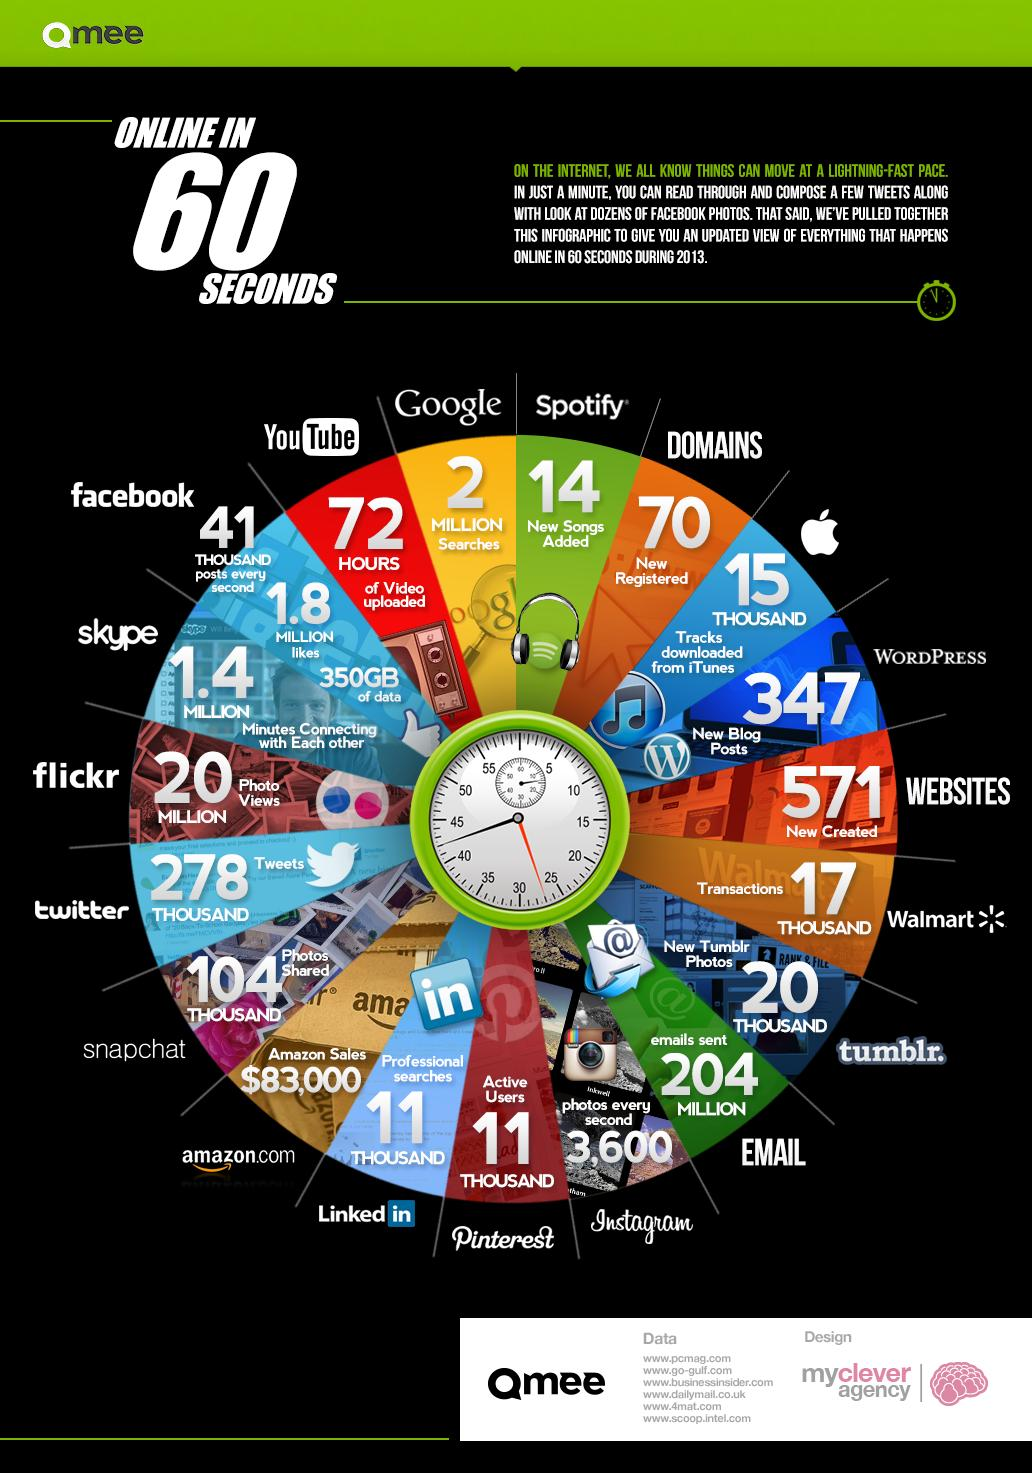List a handful of essential elements in this visual. The amount of online Amazon sales made in 60 seconds during 2013 was $83,000. During 2013, it was estimated that approximately 14 new songs were added to Spotify in 60 seconds of online activity. During 2013, a total of 571 websites were newly registered online in just one minute. In 2013, the number of domains that were newly registered online in just one minute was 70. In 2013, an estimated 2 million Google searches were conducted online in just 60 seconds. 